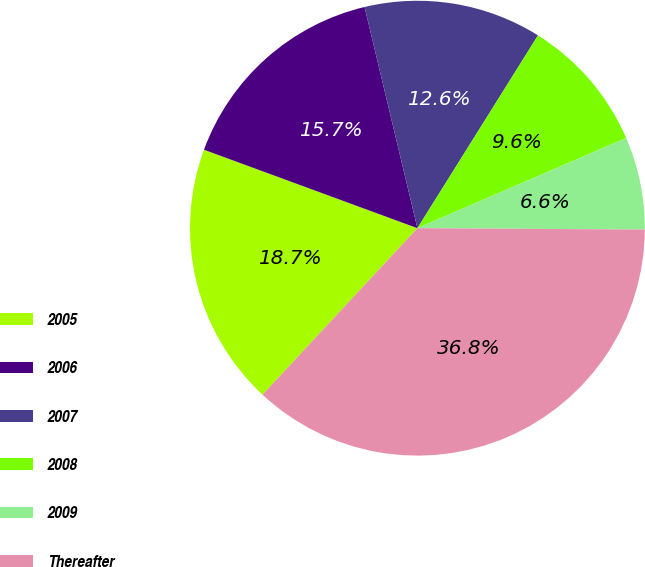<chart> <loc_0><loc_0><loc_500><loc_500><pie_chart><fcel>2005<fcel>2006<fcel>2007<fcel>2008<fcel>2009<fcel>Thereafter<nl><fcel>18.68%<fcel>15.66%<fcel>12.63%<fcel>9.61%<fcel>6.59%<fcel>36.83%<nl></chart> 